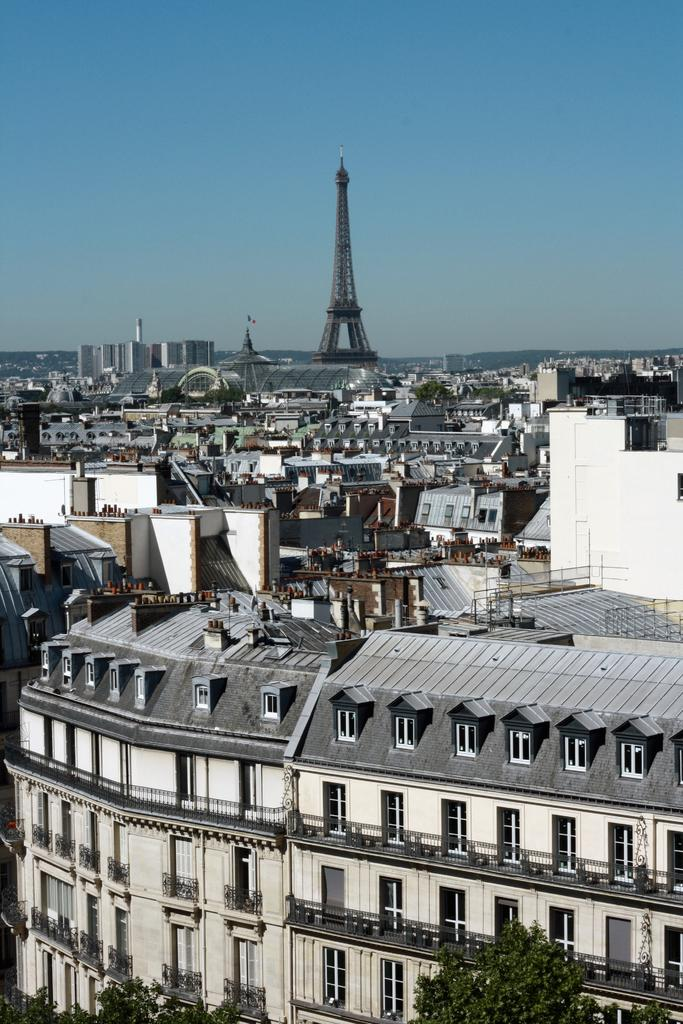What type of structures can be seen in the image? There are buildings in the image. What is the main feature in the middle of the image? There is a tower in the middle of the image. What is visible at the top of the image? The sky is visible at the top of the image. What type of vegetation can be seen at the bottom of the image? There are trees visible at the bottom of the image. How many fairies are flying around the tower in the image? There are no fairies present in the image; it only features buildings, a tower, the sky, and trees. What type of cows can be seen grazing in the fields near the buildings? There are no cows present in the image; it only features buildings, a tower, the sky, and trees. 